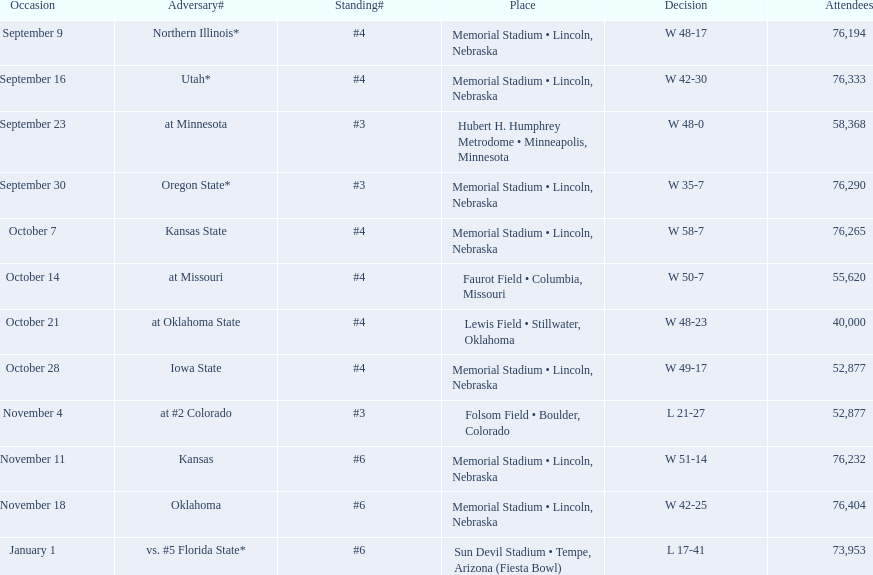How many games did they win by more than 7? 10. Can you give me this table as a dict? {'header': ['Occasion', 'Adversary#', 'Standing#', 'Place', 'Decision', 'Attendees'], 'rows': [['September 9', 'Northern Illinois*', '#4', 'Memorial Stadium • Lincoln, Nebraska', 'W\xa048-17', '76,194'], ['September 16', 'Utah*', '#4', 'Memorial Stadium • Lincoln, Nebraska', 'W\xa042-30', '76,333'], ['September 23', 'at\xa0Minnesota', '#3', 'Hubert H. Humphrey Metrodome • Minneapolis, Minnesota', 'W\xa048-0', '58,368'], ['September 30', 'Oregon State*', '#3', 'Memorial Stadium • Lincoln, Nebraska', 'W\xa035-7', '76,290'], ['October 7', 'Kansas State', '#4', 'Memorial Stadium • Lincoln, Nebraska', 'W\xa058-7', '76,265'], ['October 14', 'at\xa0Missouri', '#4', 'Faurot Field • Columbia, Missouri', 'W\xa050-7', '55,620'], ['October 21', 'at\xa0Oklahoma State', '#4', 'Lewis Field • Stillwater, Oklahoma', 'W\xa048-23', '40,000'], ['October 28', 'Iowa State', '#4', 'Memorial Stadium • Lincoln, Nebraska', 'W\xa049-17', '52,877'], ['November 4', 'at\xa0#2\xa0Colorado', '#3', 'Folsom Field • Boulder, Colorado', 'L\xa021-27', '52,877'], ['November 11', 'Kansas', '#6', 'Memorial Stadium • Lincoln, Nebraska', 'W\xa051-14', '76,232'], ['November 18', 'Oklahoma', '#6', 'Memorial Stadium • Lincoln, Nebraska', 'W\xa042-25', '76,404'], ['January 1', 'vs.\xa0#5\xa0Florida State*', '#6', 'Sun Devil Stadium • Tempe, Arizona (Fiesta Bowl)', 'L\xa017-41', '73,953']]} 